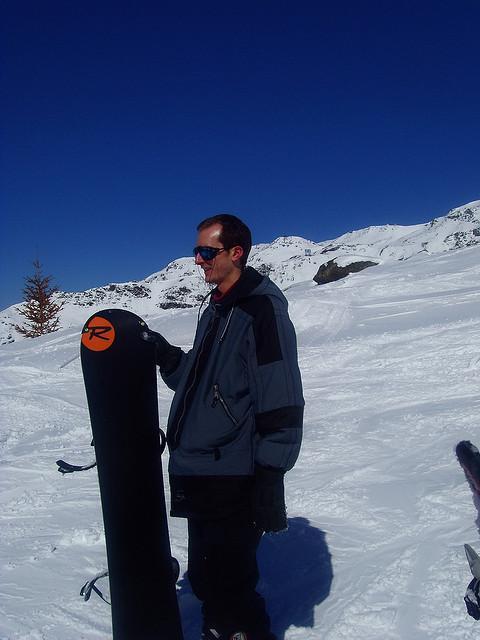How many black sheep are there?
Give a very brief answer. 0. 